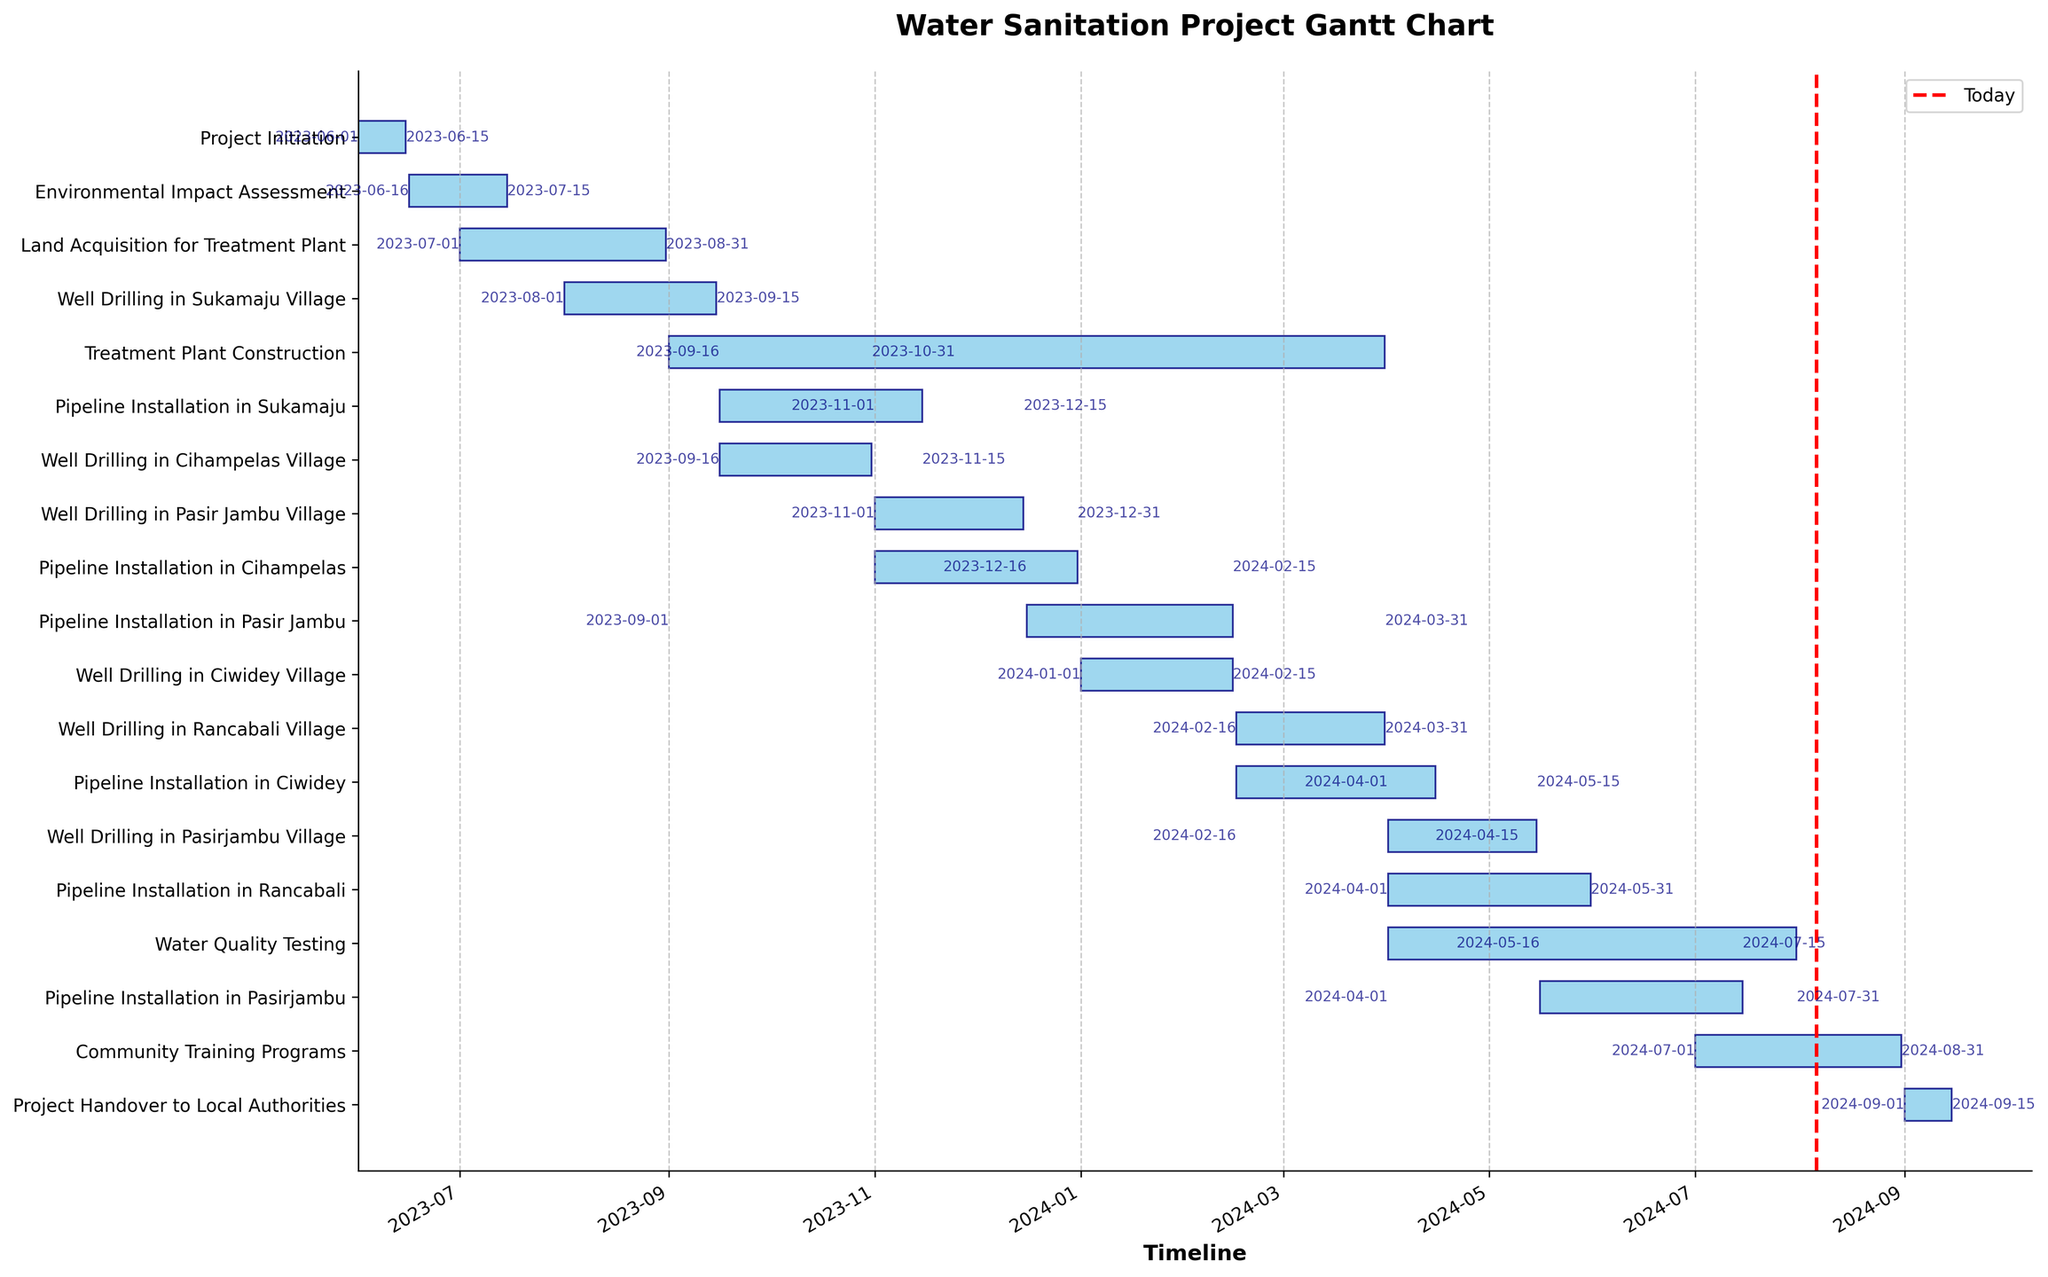What's the title of the chart? The title of the chart is found at the top of the figure. It tells us the general subject or purpose of the visualization.
Answer: Water Sanitation Project Gantt Chart How many villages have well drilling tasks scheduled? Count the unique village names mentioned in the well drilling tasks. These tasks include specific mentions of villages involved.
Answer: 8 When does the pipeline installation in Cihampelas start and end? Locate the task "Pipeline Installation in Cihampelas" and read the start and end dates directly from the chart labels next to the task bar.
Answer: Starts on 2023-11-01 and ends on 2023-12-31 Which task starts immediately after the "Well Drilling in Sukamaju Village"? Find the end date of "Well Drilling in Sukamaju Village", then look for the next task that starts after this date in chronological order.
Answer: Pipeline Installation in Sukamaju How long is the "Environmental Impact Assessment" phase? Calculate the duration of the "Environmental Impact Assessment" by subtracting its start date from its end date.
Answer: 29 days How many months does it take to complete the "Treatment Plant Construction"? Determine the start and end dates of "Treatment Plant Construction", then count the complete and partial months between these dates.
Answer: About 7 months Is there any overlap between the "Water Quality Testing" and "Community Training Programs"? Check the start and end dates of both tasks to see if their durations overlap in time.
Answer: Yes What is the last task scheduled in the project? Find the task with the latest end date by examining all the tasks and their respective end dates.
Answer: Project Handover to Local Authorities Which task has the longest duration? Calculate the duration of each task by subtracting its start date from its end date, then compare these durations to find the longest.
Answer: Treatment Plant Construction Do any well drilling tasks happen simultaneously in different villages? Examine the start and end dates of all well drilling tasks to identify any overlaps in their timeframes.
Answer: Yes, Well Drilling in Pasirjambu (2024-04-01 to 2024-05-15) overlaps with Well Drilling in Rancabali Village (2024-02-16 to 2024-03-31) 